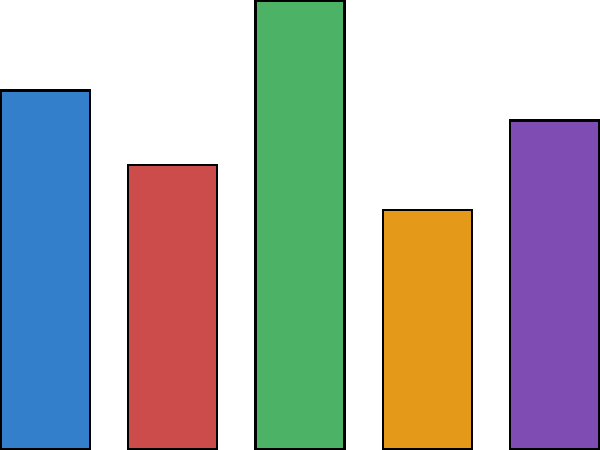Based on the bar graph showing attendance rates for different workshop topics, which topic attracted the highest number of attendees, and how many more attendees did it have compared to the least popular workshop? To answer this question, we need to follow these steps:

1. Identify the workshop topic with the highest attendance:
   By examining the bar heights, we can see that "Communication" has the tallest bar.

2. Find the number of attendees for the Communication workshop:
   The y-axis shows that the Communication bar reaches 150 attendees.

3. Identify the workshop topic with the lowest attendance:
   The shortest bar corresponds to "Anger Management".

4. Find the number of attendees for the Anger Management workshop:
   The Anger Management bar reaches 80 attendees on the y-axis.

5. Calculate the difference between the highest and lowest attended workshops:
   $150 - 80 = 70$ attendees

Therefore, the Communication workshop had the highest attendance, with 70 more attendees than the least popular workshop (Anger Management).
Answer: Communication; 70 attendees 